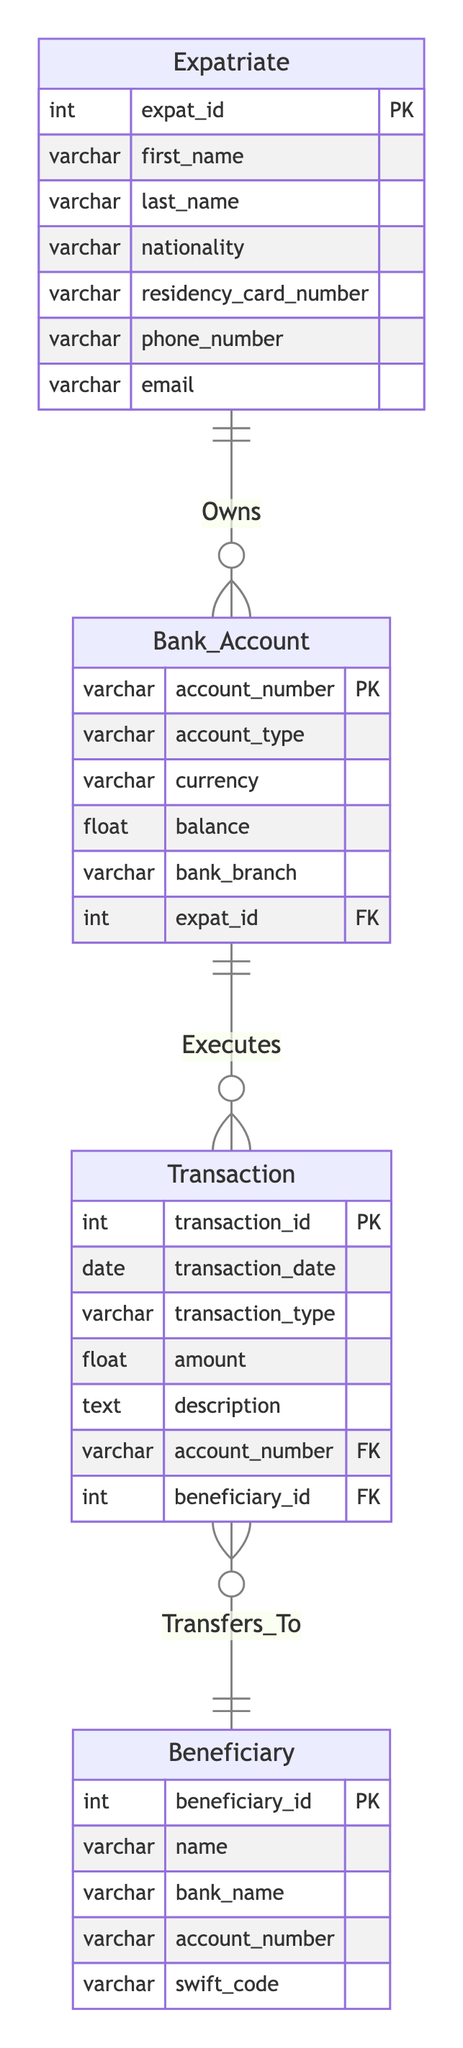What is the primary key of the Expatriate entity? The Expatriate entity has a primary key attribute named "expat_id," which uniquely identifies each expatriate in the diagram.
Answer: expat_id How many entities are represented in the diagram? The diagram contains four entities: Expatriate, Bank Account, Transaction, and Beneficiary, which can be counted directly from the visual.
Answer: four What type of relationship exists between Bank Account and Transaction? The relationship between Bank Account and Transaction is one-to-many, indicating that a single bank account can have multiple associated transactions.
Answer: one-to-many How many attributes does the Beneficiary entity have? The Beneficiary entity has five attributes listed: beneficiary_id, name, bank_name, account_number, and swift_code, which can be identified in the diagram.
Answer: five Which entity owns a bank account? The diagram indicates that the Expatriate entity owns a bank account, shown by the relationship labeled "Owns" connecting the two entities.
Answer: Expatriate What is the foreign key in the Transaction entity? The Transaction entity has two foreign keys: "account_number," which references the Bank Account entity, and "beneficiary_id," which references the Beneficiary entity, illustrating linkages to other entities.
Answer: account_number, beneficiary_id Who is able to execute transactions? The entities capable of executing transactions are the Bank Account entities, as shown by the relationship labeled "Executes" connecting Bank Account to Transaction.
Answer: Bank Account What is the primary key of the Transaction entity? The primary key of the Transaction entity is "transaction_id," which uniquely identifies each transaction in the database.
Answer: transaction_id 